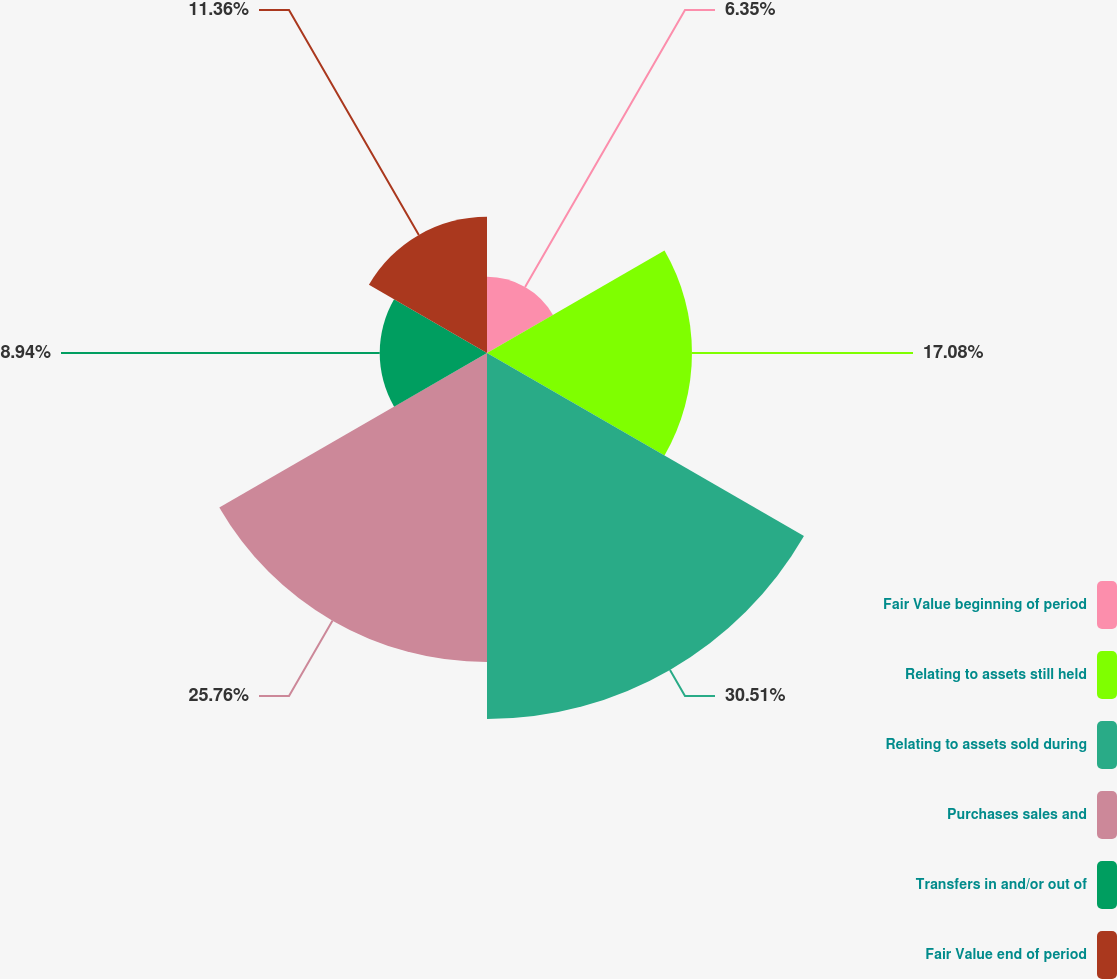<chart> <loc_0><loc_0><loc_500><loc_500><pie_chart><fcel>Fair Value beginning of period<fcel>Relating to assets still held<fcel>Relating to assets sold during<fcel>Purchases sales and<fcel>Transfers in and/or out of<fcel>Fair Value end of period<nl><fcel>6.35%<fcel>17.08%<fcel>30.5%<fcel>25.76%<fcel>8.94%<fcel>11.36%<nl></chart> 